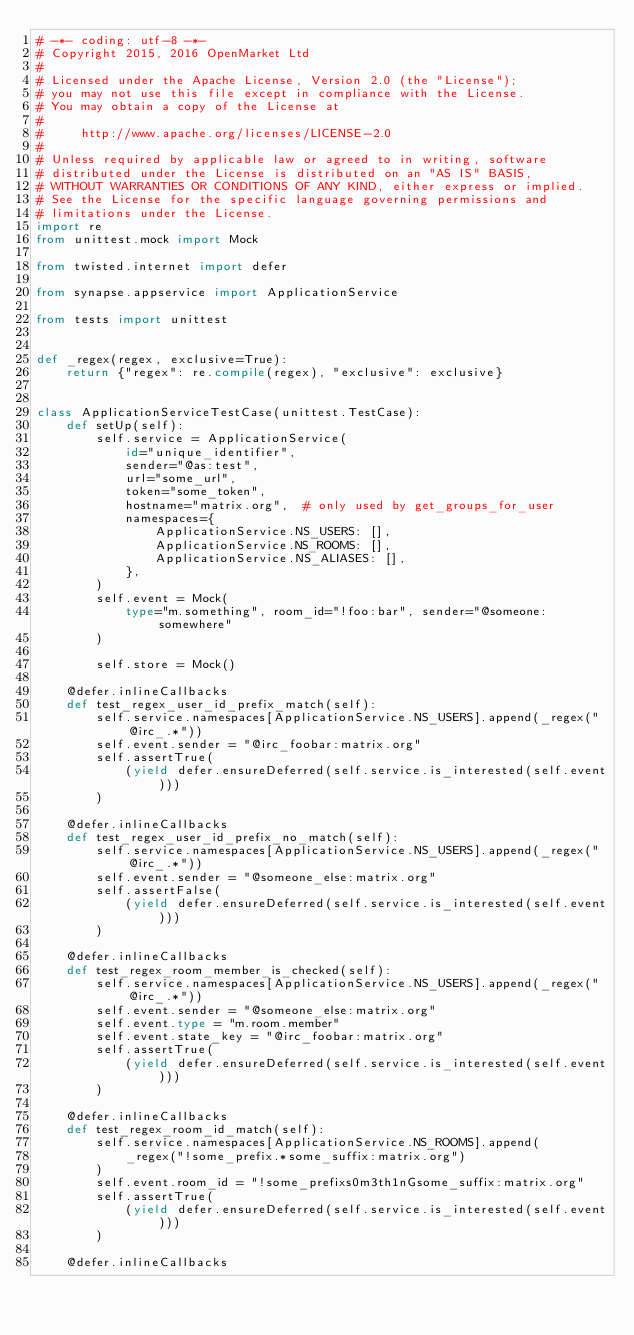Convert code to text. <code><loc_0><loc_0><loc_500><loc_500><_Python_># -*- coding: utf-8 -*-
# Copyright 2015, 2016 OpenMarket Ltd
#
# Licensed under the Apache License, Version 2.0 (the "License");
# you may not use this file except in compliance with the License.
# You may obtain a copy of the License at
#
#     http://www.apache.org/licenses/LICENSE-2.0
#
# Unless required by applicable law or agreed to in writing, software
# distributed under the License is distributed on an "AS IS" BASIS,
# WITHOUT WARRANTIES OR CONDITIONS OF ANY KIND, either express or implied.
# See the License for the specific language governing permissions and
# limitations under the License.
import re
from unittest.mock import Mock

from twisted.internet import defer

from synapse.appservice import ApplicationService

from tests import unittest


def _regex(regex, exclusive=True):
    return {"regex": re.compile(regex), "exclusive": exclusive}


class ApplicationServiceTestCase(unittest.TestCase):
    def setUp(self):
        self.service = ApplicationService(
            id="unique_identifier",
            sender="@as:test",
            url="some_url",
            token="some_token",
            hostname="matrix.org",  # only used by get_groups_for_user
            namespaces={
                ApplicationService.NS_USERS: [],
                ApplicationService.NS_ROOMS: [],
                ApplicationService.NS_ALIASES: [],
            },
        )
        self.event = Mock(
            type="m.something", room_id="!foo:bar", sender="@someone:somewhere"
        )

        self.store = Mock()

    @defer.inlineCallbacks
    def test_regex_user_id_prefix_match(self):
        self.service.namespaces[ApplicationService.NS_USERS].append(_regex("@irc_.*"))
        self.event.sender = "@irc_foobar:matrix.org"
        self.assertTrue(
            (yield defer.ensureDeferred(self.service.is_interested(self.event)))
        )

    @defer.inlineCallbacks
    def test_regex_user_id_prefix_no_match(self):
        self.service.namespaces[ApplicationService.NS_USERS].append(_regex("@irc_.*"))
        self.event.sender = "@someone_else:matrix.org"
        self.assertFalse(
            (yield defer.ensureDeferred(self.service.is_interested(self.event)))
        )

    @defer.inlineCallbacks
    def test_regex_room_member_is_checked(self):
        self.service.namespaces[ApplicationService.NS_USERS].append(_regex("@irc_.*"))
        self.event.sender = "@someone_else:matrix.org"
        self.event.type = "m.room.member"
        self.event.state_key = "@irc_foobar:matrix.org"
        self.assertTrue(
            (yield defer.ensureDeferred(self.service.is_interested(self.event)))
        )

    @defer.inlineCallbacks
    def test_regex_room_id_match(self):
        self.service.namespaces[ApplicationService.NS_ROOMS].append(
            _regex("!some_prefix.*some_suffix:matrix.org")
        )
        self.event.room_id = "!some_prefixs0m3th1nGsome_suffix:matrix.org"
        self.assertTrue(
            (yield defer.ensureDeferred(self.service.is_interested(self.event)))
        )

    @defer.inlineCallbacks</code> 